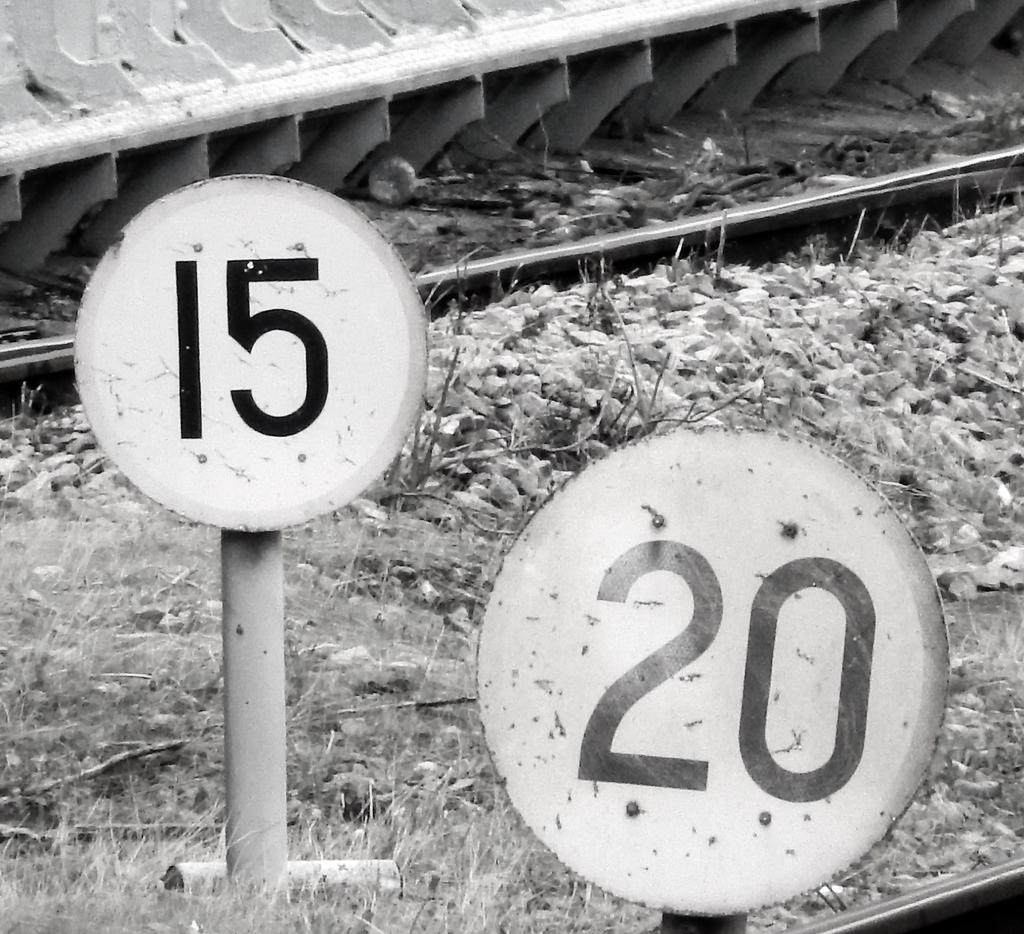What number is on the right sign?
Ensure brevity in your answer.  20. What number is on the left sign?
Offer a very short reply. 15. 